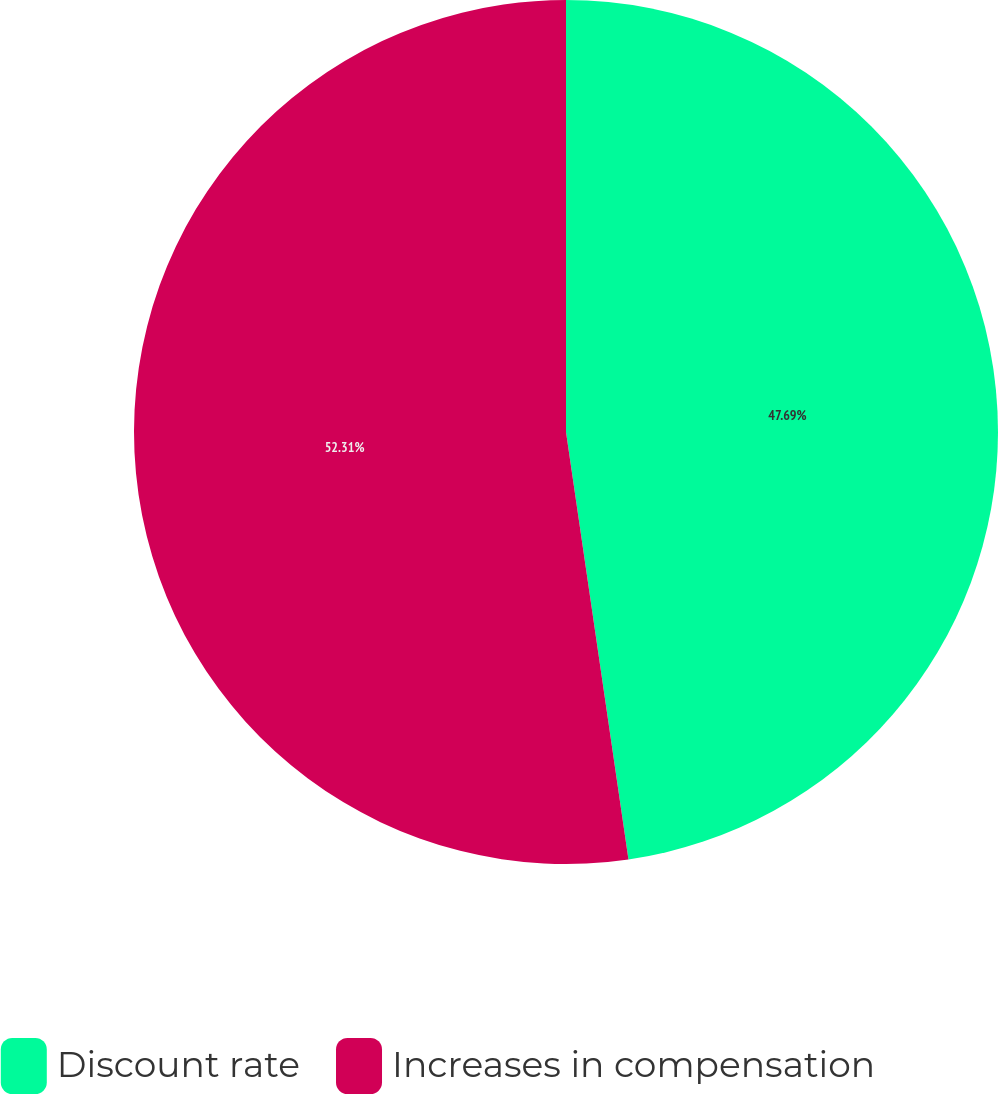Convert chart to OTSL. <chart><loc_0><loc_0><loc_500><loc_500><pie_chart><fcel>Discount rate<fcel>Increases in compensation<nl><fcel>47.69%<fcel>52.31%<nl></chart> 